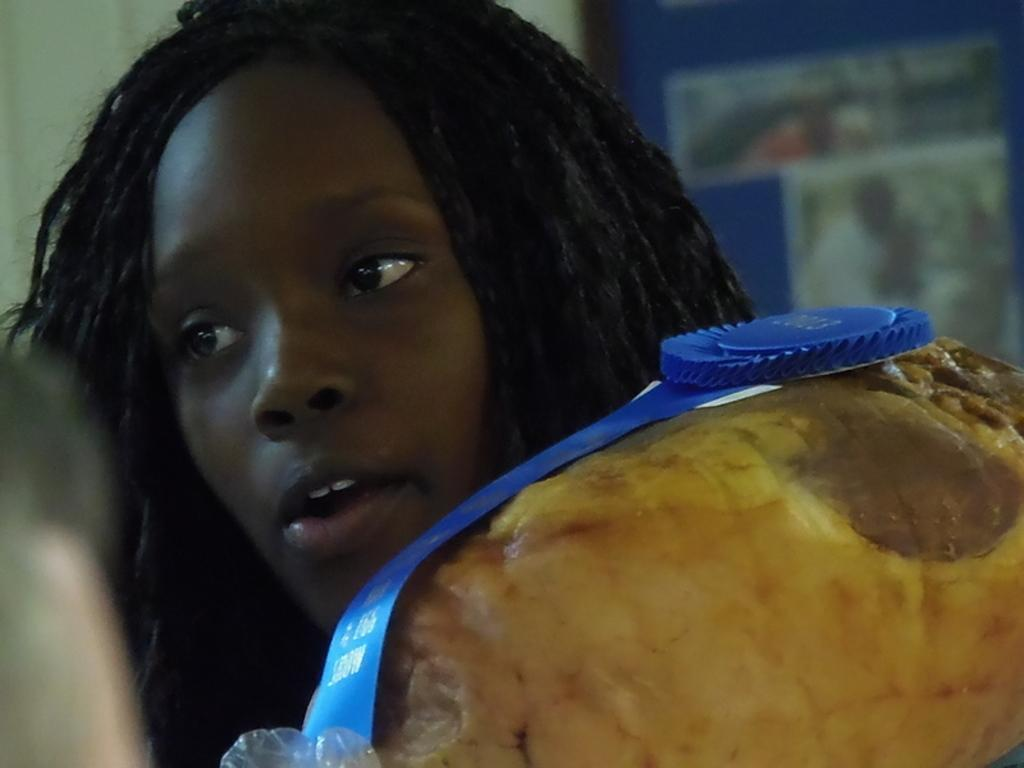Who is the main subject in the picture? There is an African girl in the picture. What type of food is visible in the image? There is yellow-colored food in the image. How is the food decorated or presented? The food has a blue-colored ribbon on top. Can you describe the background of the image? The background of the image is blurred. How many babies are present in the image? There are no babies present in the image; it features an African girl and yellow-colored food. What type of division is being performed in the image? There is no division being performed in the image; it shows an African girl and yellow-colored food with a blue-colored ribbon on top. 